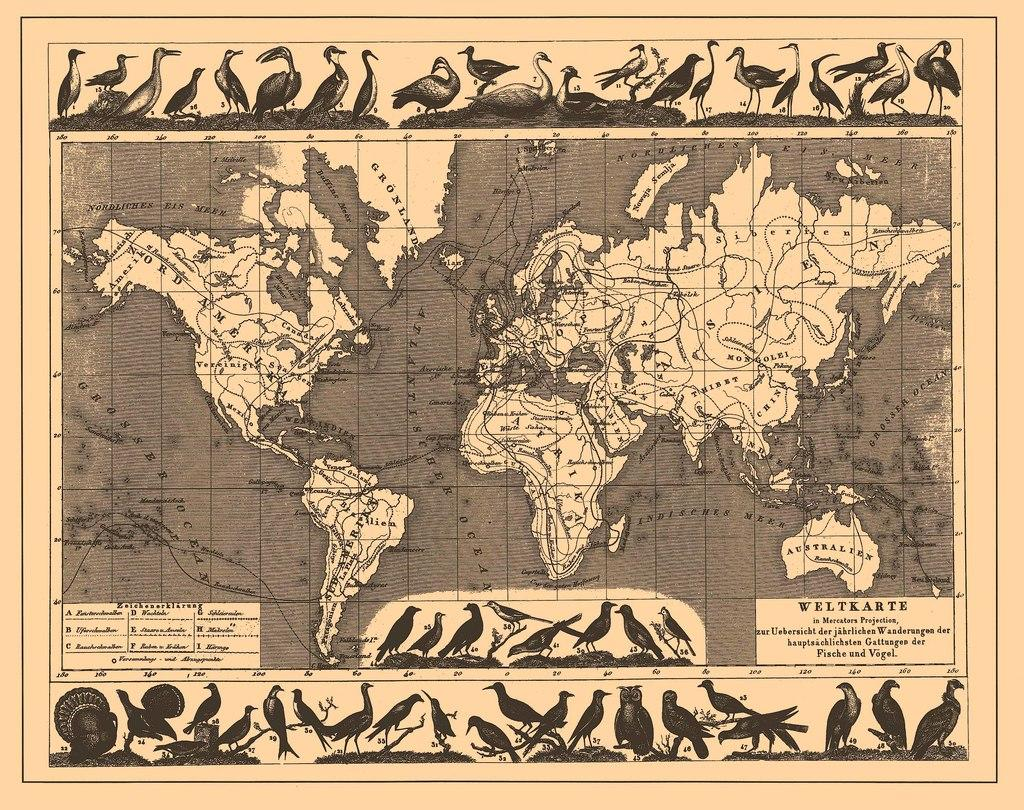What is featured on the poster in the image? The poster contains images of birds and a world map. What else can be found on the poster besides the images and map? There is text on the poster. What type of stem can be seen growing from the world map on the poster? There is no stem growing from the world map on the poster; it is a flat, printed image. 